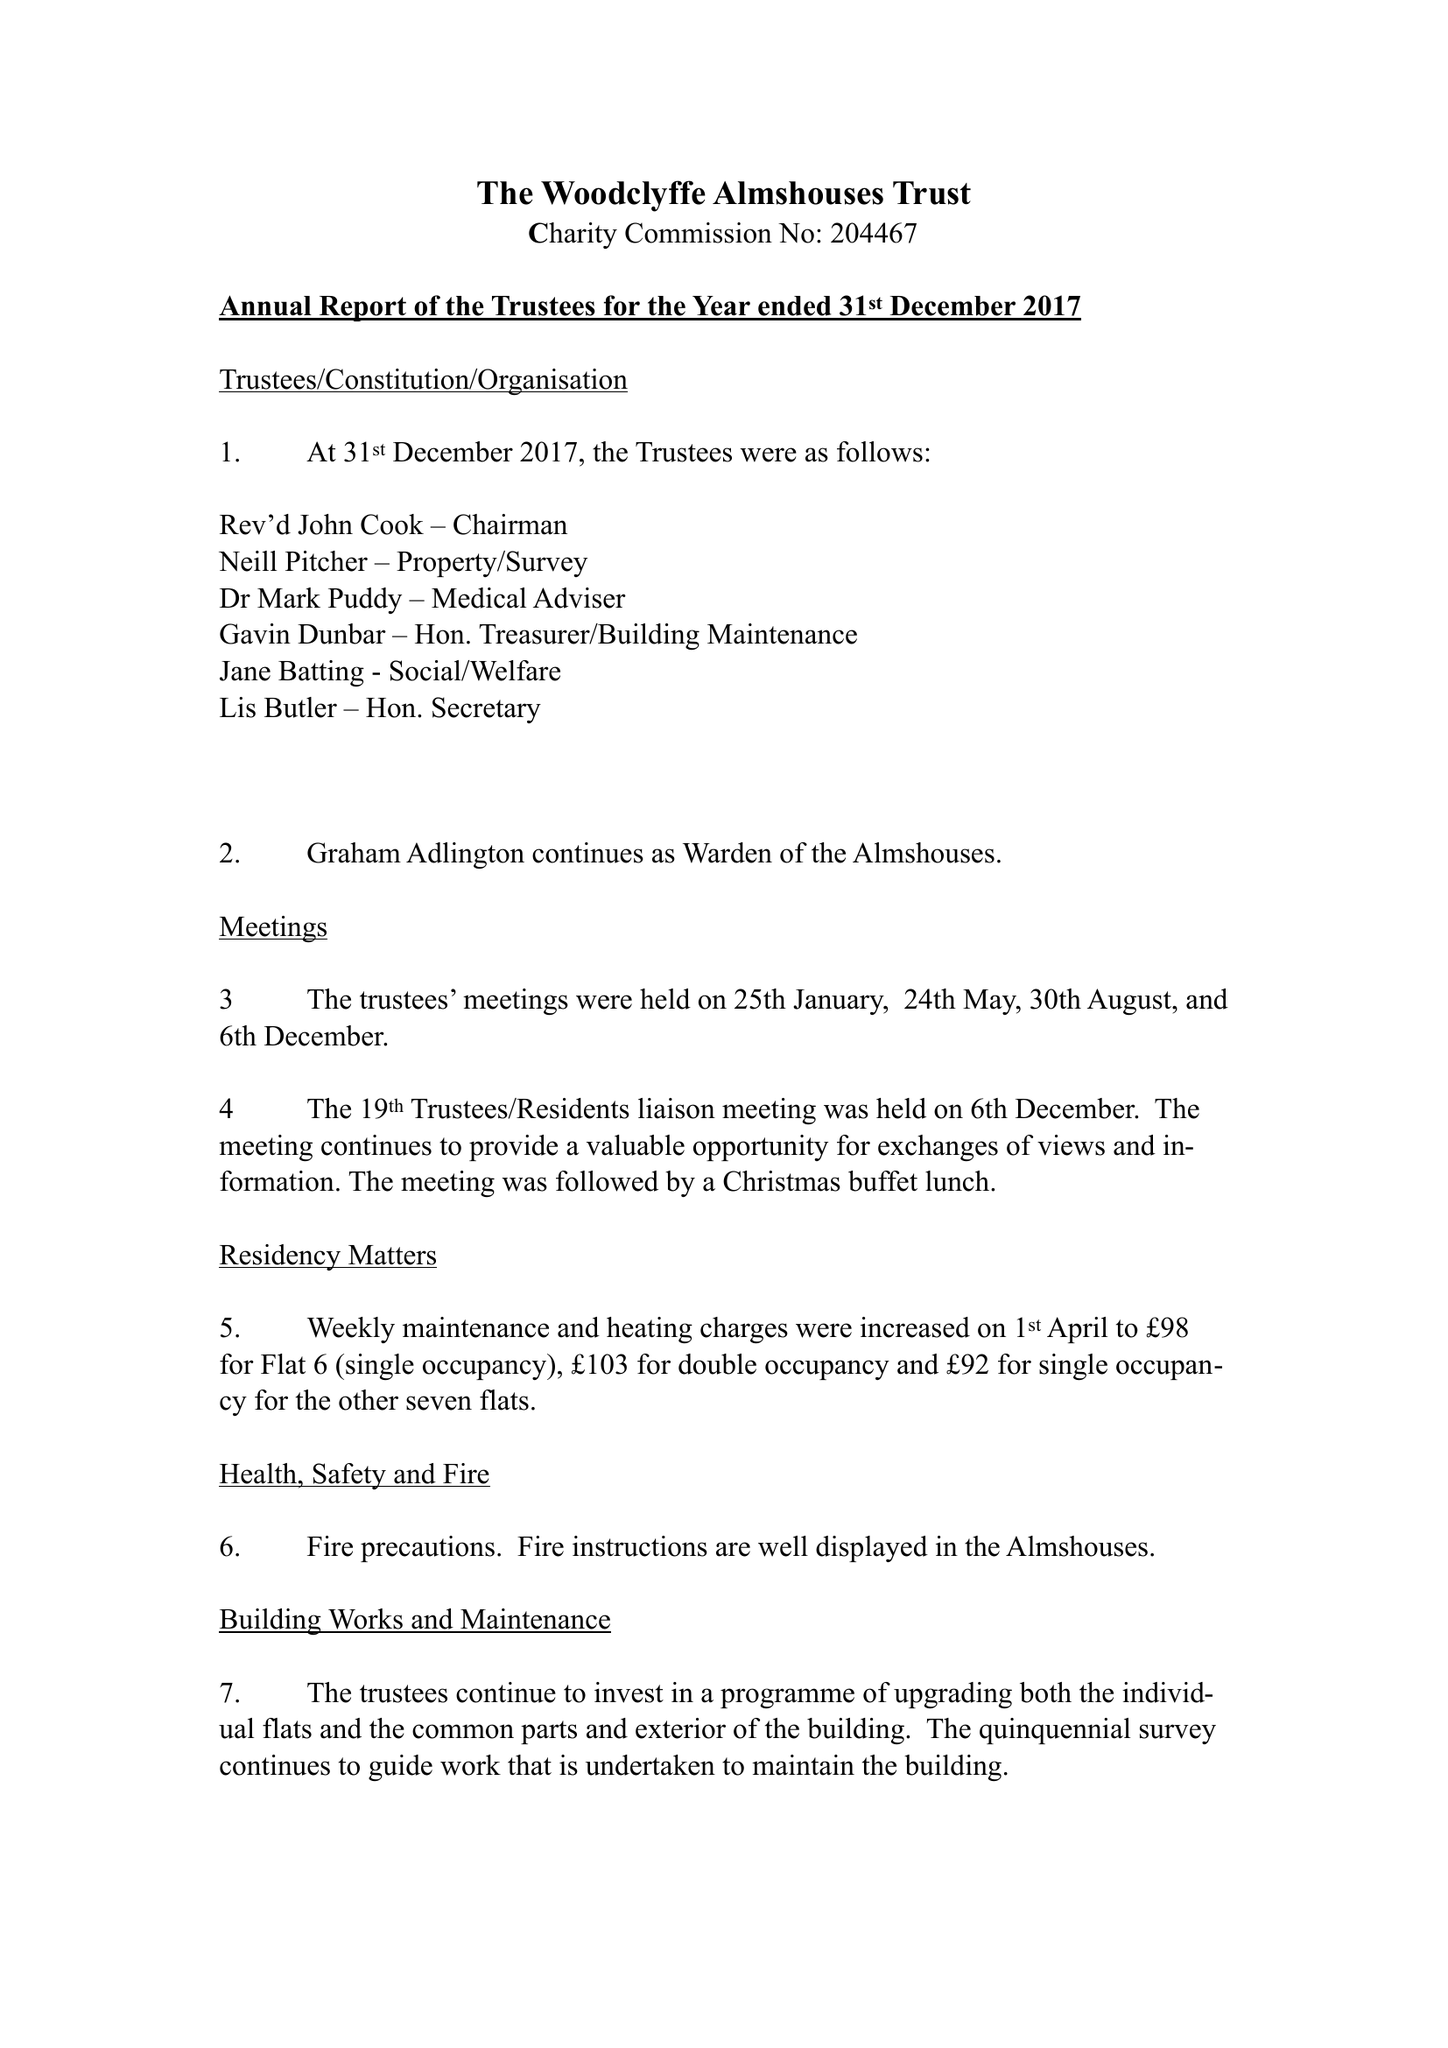What is the value for the address__postcode?
Answer the question using a single word or phrase. RG10 8HY 